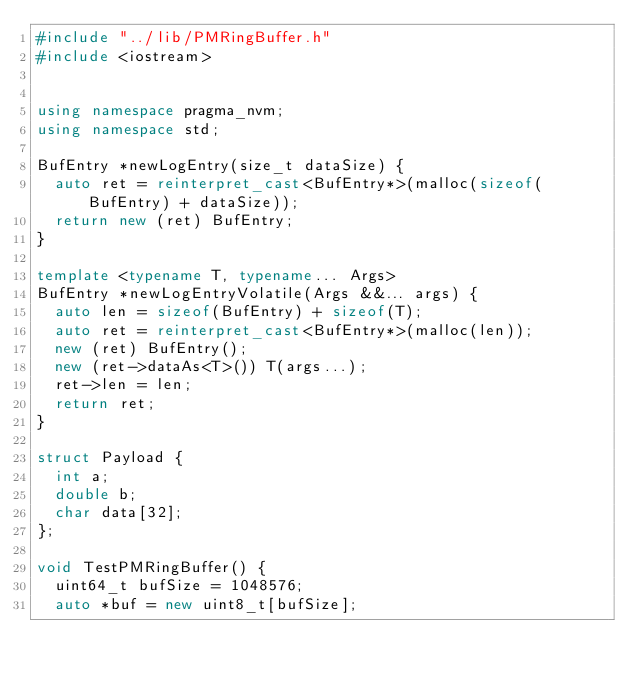<code> <loc_0><loc_0><loc_500><loc_500><_C++_>#include "../lib/PMRingBuffer.h"
#include <iostream>


using namespace pragma_nvm;
using namespace std;

BufEntry *newLogEntry(size_t dataSize) {
  auto ret = reinterpret_cast<BufEntry*>(malloc(sizeof(BufEntry) + dataSize));
  return new (ret) BufEntry;
}

template <typename T, typename... Args>
BufEntry *newLogEntryVolatile(Args &&... args) {
  auto len = sizeof(BufEntry) + sizeof(T);
  auto ret = reinterpret_cast<BufEntry*>(malloc(len));
  new (ret) BufEntry();
  new (ret->dataAs<T>()) T(args...);
  ret->len = len;
  return ret;
}

struct Payload {
  int a;
  double b;
  char data[32];
};

void TestPMRingBuffer() {
  uint64_t bufSize = 1048576;
  auto *buf = new uint8_t[bufSize];</code> 